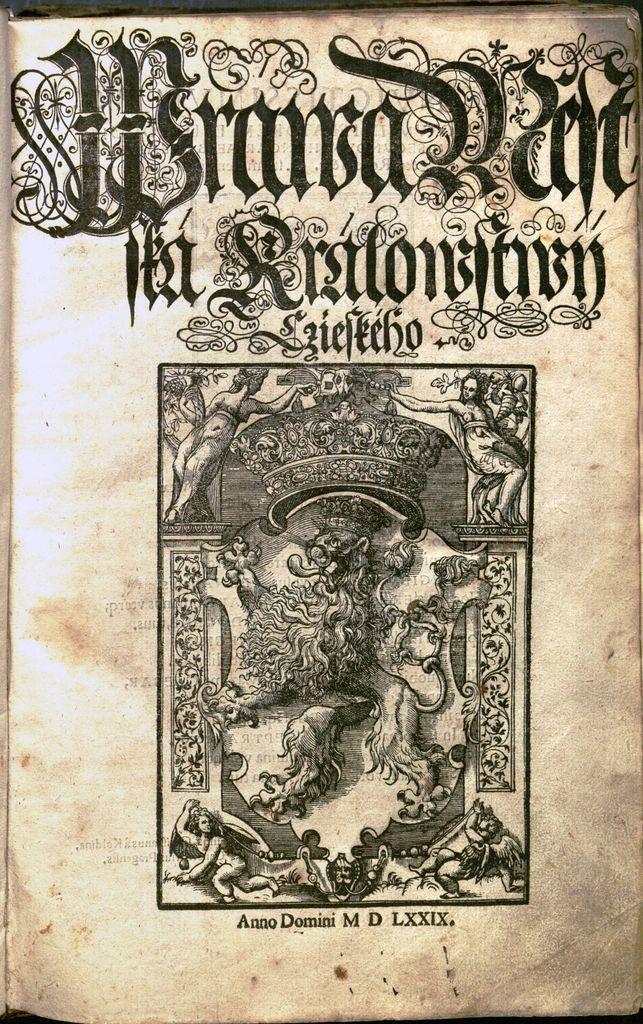What are the last 5 letters printed at the bottom of this page?
Ensure brevity in your answer.  Lxxix. Is this an anno domini book?
Offer a terse response. Yes. 